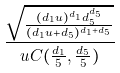<formula> <loc_0><loc_0><loc_500><loc_500>\frac { \sqrt { \frac { ( d _ { 1 } u ) ^ { d _ { 1 } } d _ { 5 } ^ { d _ { 5 } } } { ( d _ { 1 } u + d _ { 5 } ) ^ { d _ { 1 } + d _ { 5 } } } } } { u C ( \frac { d _ { 1 } } { 5 } , \frac { d _ { 5 } } { 5 } ) }</formula> 